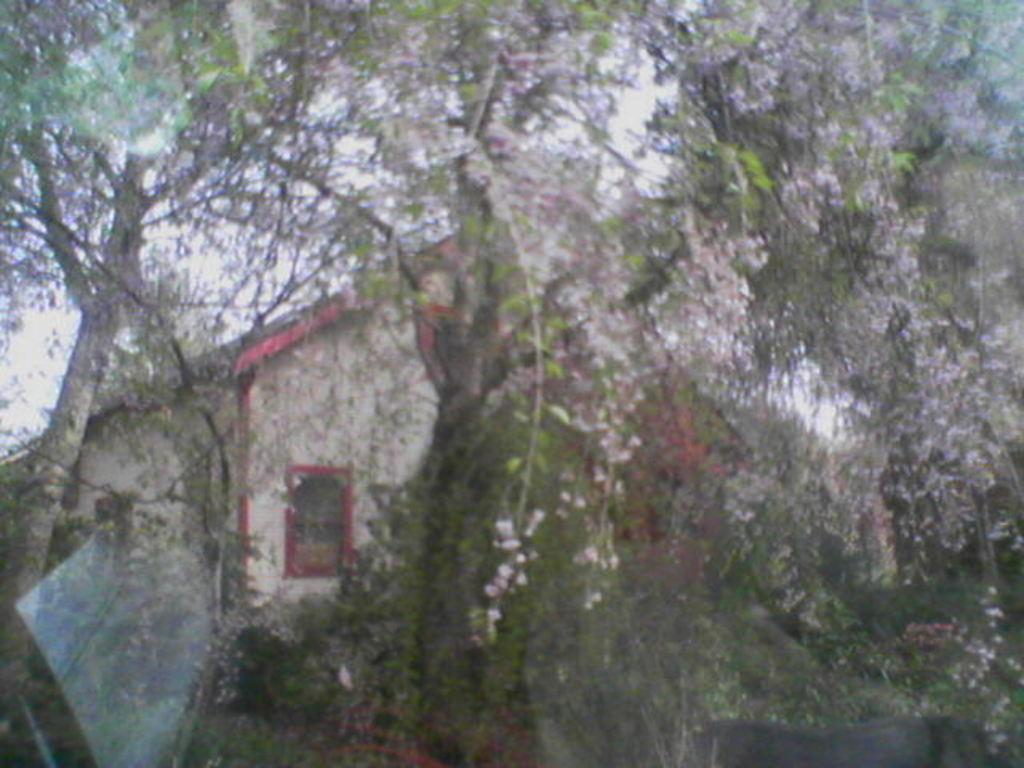What is the main subject in the middle of the image? There is a house in the middle of the image. What can be seen in front of the house? There are trees in front of the house. What is visible at the top of the image? The sky is visible at the top of the image. What type of punishment is being given to the house in the image? There is no punishment being given to the house in the image; it is just a stationary building. 